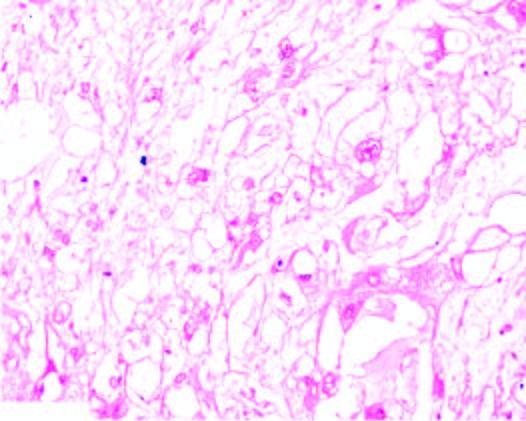s the background myxoid?
Answer the question using a single word or phrase. Yes 